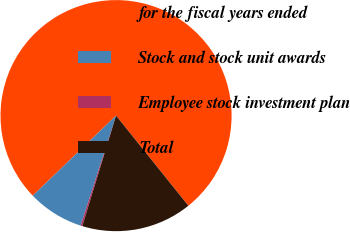Convert chart. <chart><loc_0><loc_0><loc_500><loc_500><pie_chart><fcel>for the fiscal years ended<fcel>Stock and stock unit awards<fcel>Employee stock investment plan<fcel>Total<nl><fcel>76.42%<fcel>7.86%<fcel>0.24%<fcel>15.48%<nl></chart> 